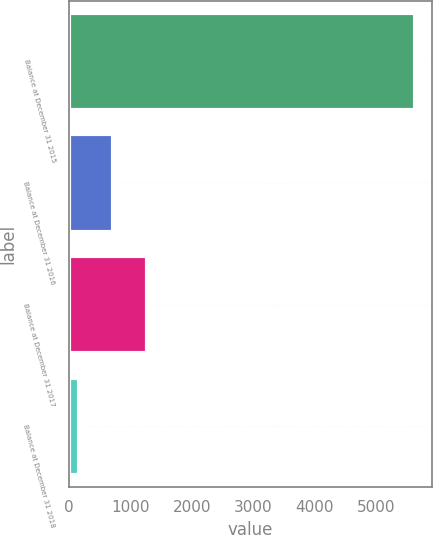Convert chart. <chart><loc_0><loc_0><loc_500><loc_500><bar_chart><fcel>Balance at December 31 2015<fcel>Balance at December 31 2016<fcel>Balance at December 31 2017<fcel>Balance at December 31 2018<nl><fcel>5635<fcel>715.6<fcel>1262.2<fcel>169<nl></chart> 